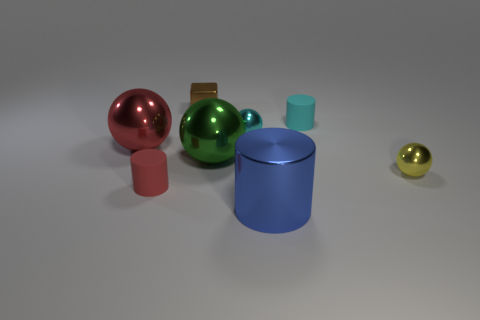Are there any tiny brown things that have the same material as the blue thing?
Provide a short and direct response. Yes. The metallic block is what color?
Your answer should be compact. Brown. There is a red metal ball that is left of the shiny thing that is in front of the cylinder on the left side of the blue metallic object; what size is it?
Give a very brief answer. Large. How many other objects are there of the same shape as the small cyan shiny thing?
Make the answer very short. 3. What color is the big object that is to the right of the large red metallic sphere and left of the large blue metal cylinder?
Offer a very short reply. Green. There is a small shiny ball that is on the left side of the yellow thing; does it have the same color as the shiny block?
Your response must be concise. No. What number of spheres are either small yellow metallic objects or small red rubber objects?
Your response must be concise. 1. The tiny matte thing that is behind the red rubber cylinder has what shape?
Provide a succinct answer. Cylinder. The small metal sphere that is to the left of the tiny yellow metallic object in front of the tiny cylinder that is behind the red metal ball is what color?
Your answer should be very brief. Cyan. Are the cyan ball and the large red thing made of the same material?
Give a very brief answer. Yes. 